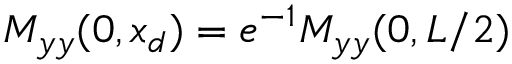<formula> <loc_0><loc_0><loc_500><loc_500>M _ { y y } ( 0 , x _ { d } ) = e ^ { - 1 } M _ { y y } ( 0 , L / 2 )</formula> 